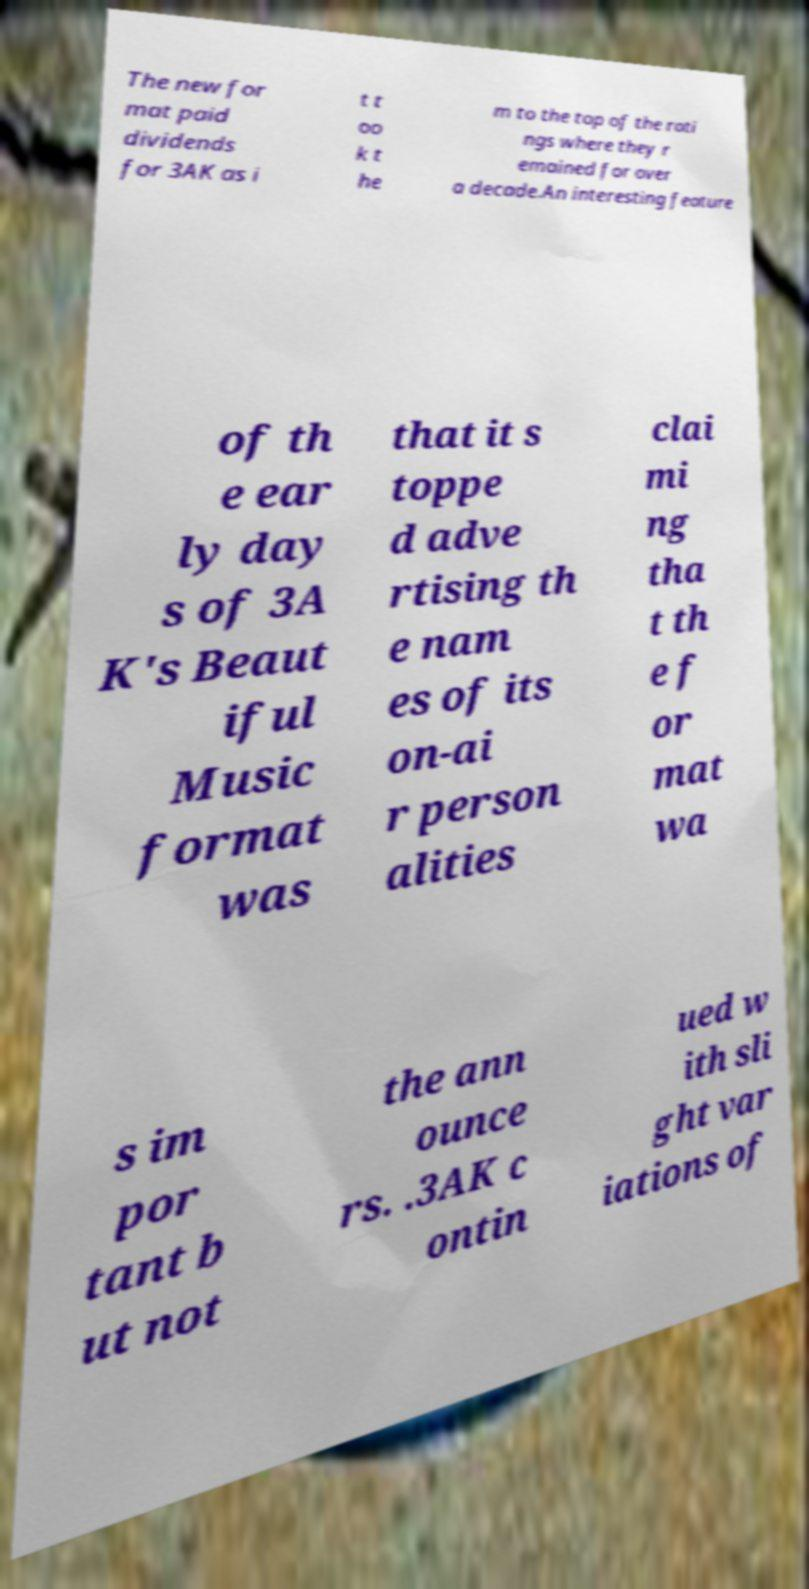For documentation purposes, I need the text within this image transcribed. Could you provide that? The new for mat paid dividends for 3AK as i t t oo k t he m to the top of the rati ngs where they r emained for over a decade.An interesting feature of th e ear ly day s of 3A K's Beaut iful Music format was that it s toppe d adve rtising th e nam es of its on-ai r person alities clai mi ng tha t th e f or mat wa s im por tant b ut not the ann ounce rs. .3AK c ontin ued w ith sli ght var iations of 